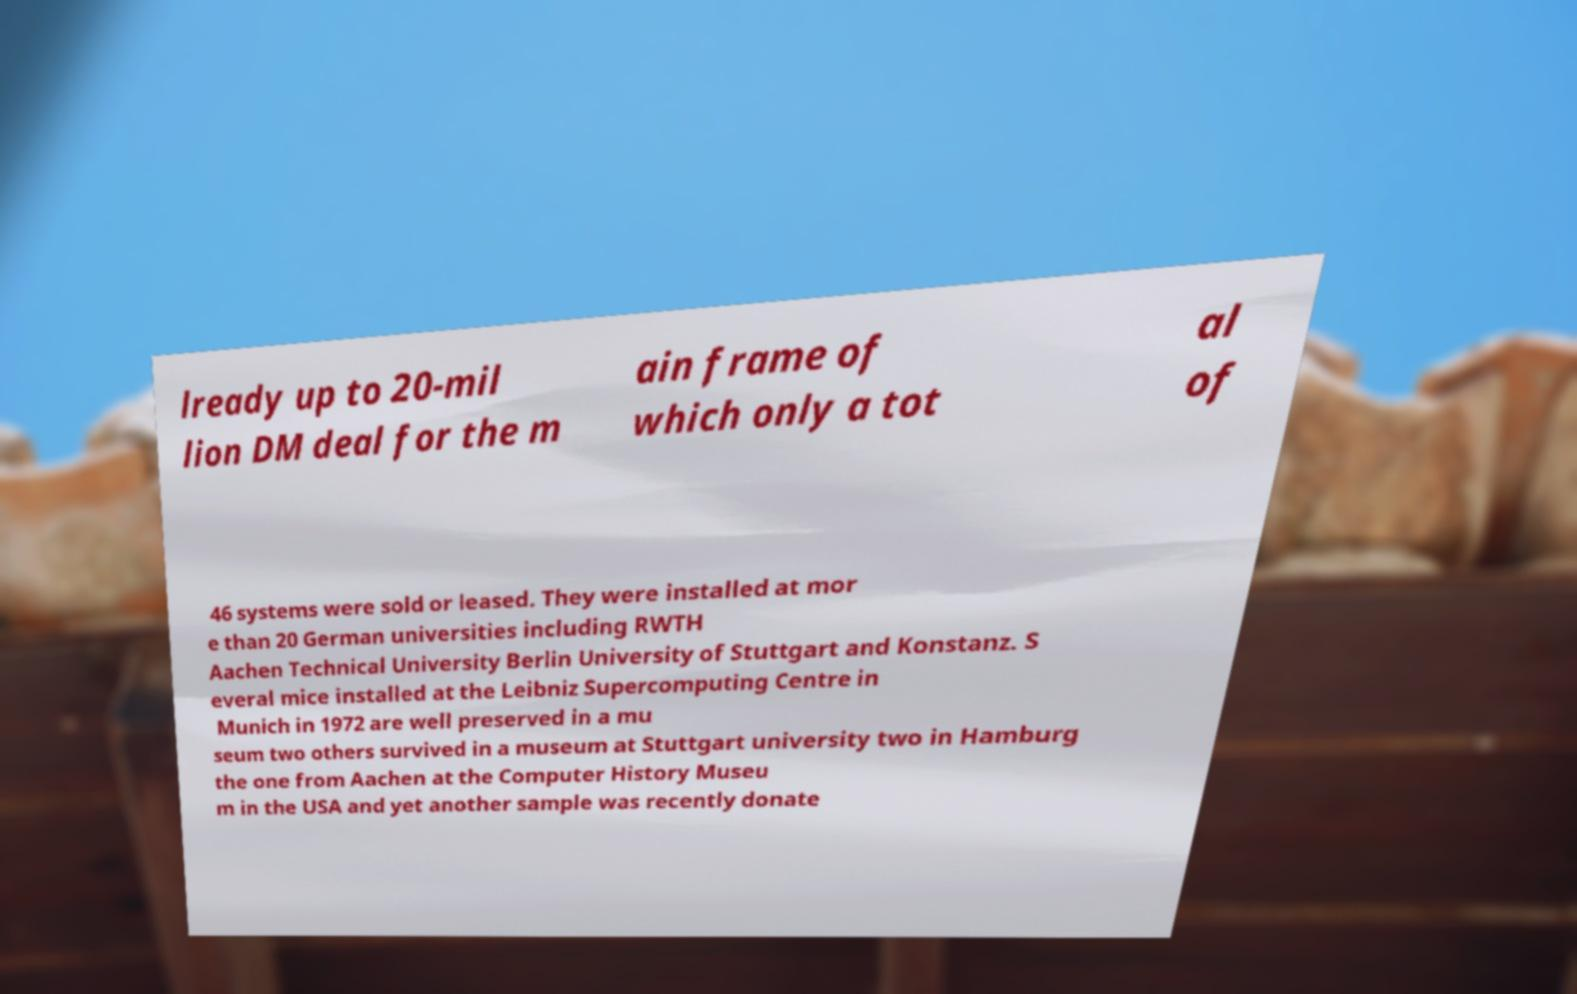There's text embedded in this image that I need extracted. Can you transcribe it verbatim? lready up to 20-mil lion DM deal for the m ain frame of which only a tot al of 46 systems were sold or leased. They were installed at mor e than 20 German universities including RWTH Aachen Technical University Berlin University of Stuttgart and Konstanz. S everal mice installed at the Leibniz Supercomputing Centre in Munich in 1972 are well preserved in a mu seum two others survived in a museum at Stuttgart university two in Hamburg the one from Aachen at the Computer History Museu m in the USA and yet another sample was recently donate 